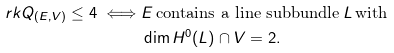<formula> <loc_0><loc_0><loc_500><loc_500>\ r k Q _ { ( E , V ) } \leq 4 \iff & E \, \text {contains a line subbundle} \, L \, \text {with} \\ & \dim H ^ { 0 } ( L ) \cap V = 2 .</formula> 